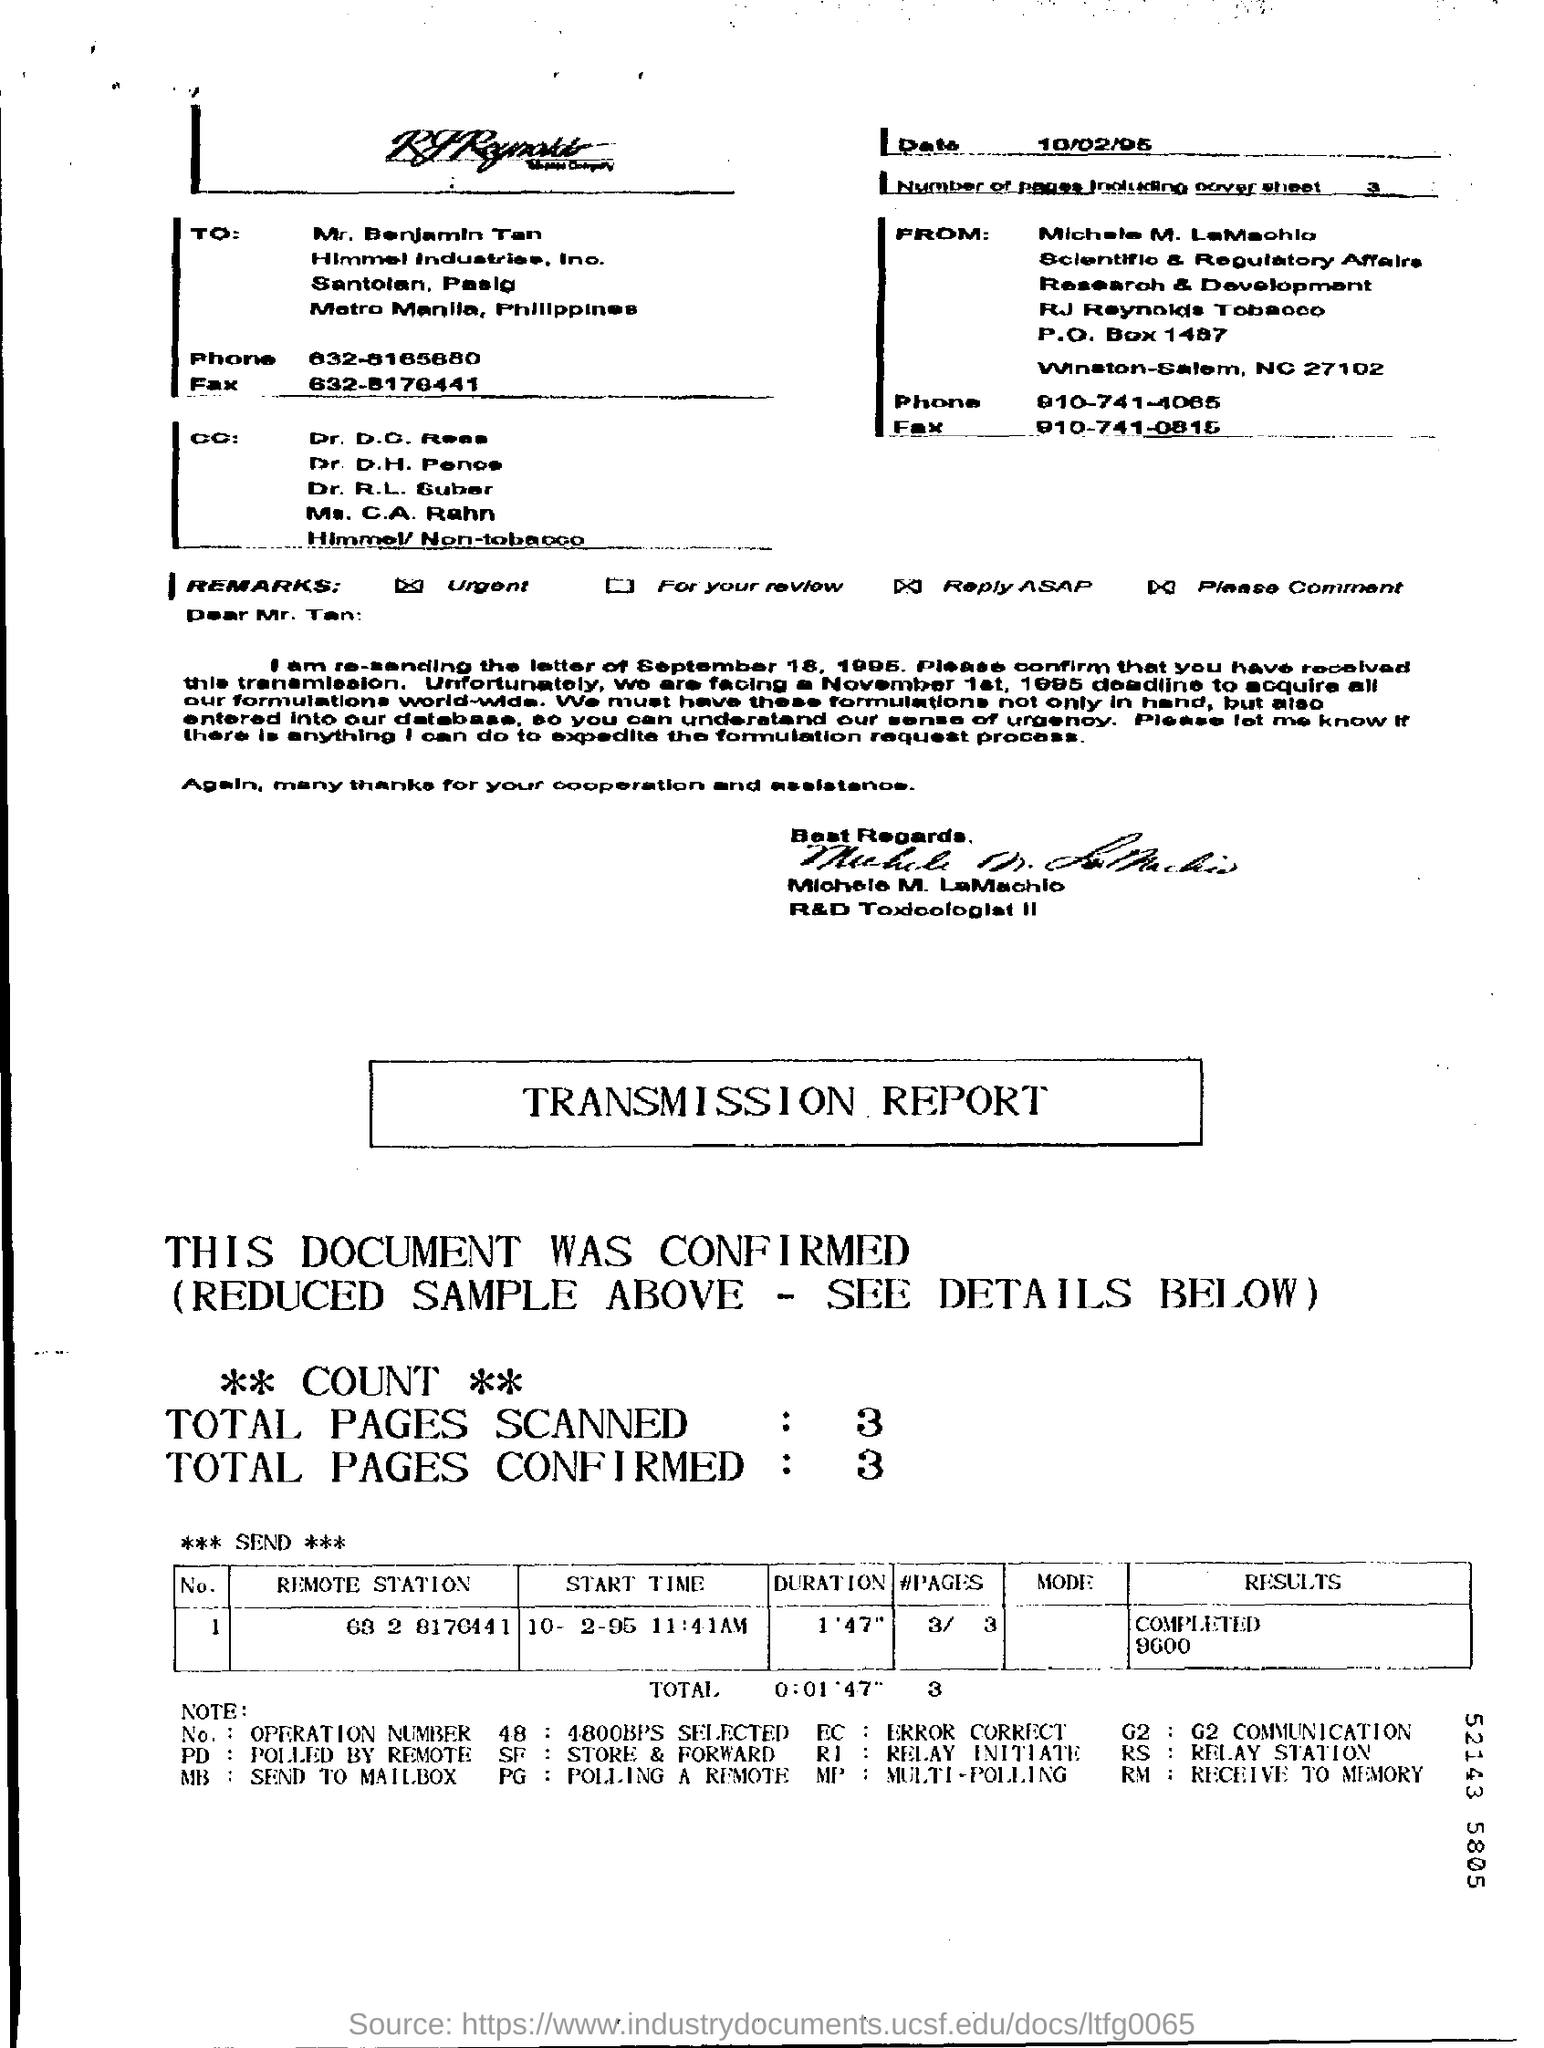Draw attention to some important aspects in this diagram. The number of pages in the fax, including the cover sheet, is three. The recipient of the fax is Mr. Benjamin Tan. The duration mentioned in the transmission report is 0:01'47. 